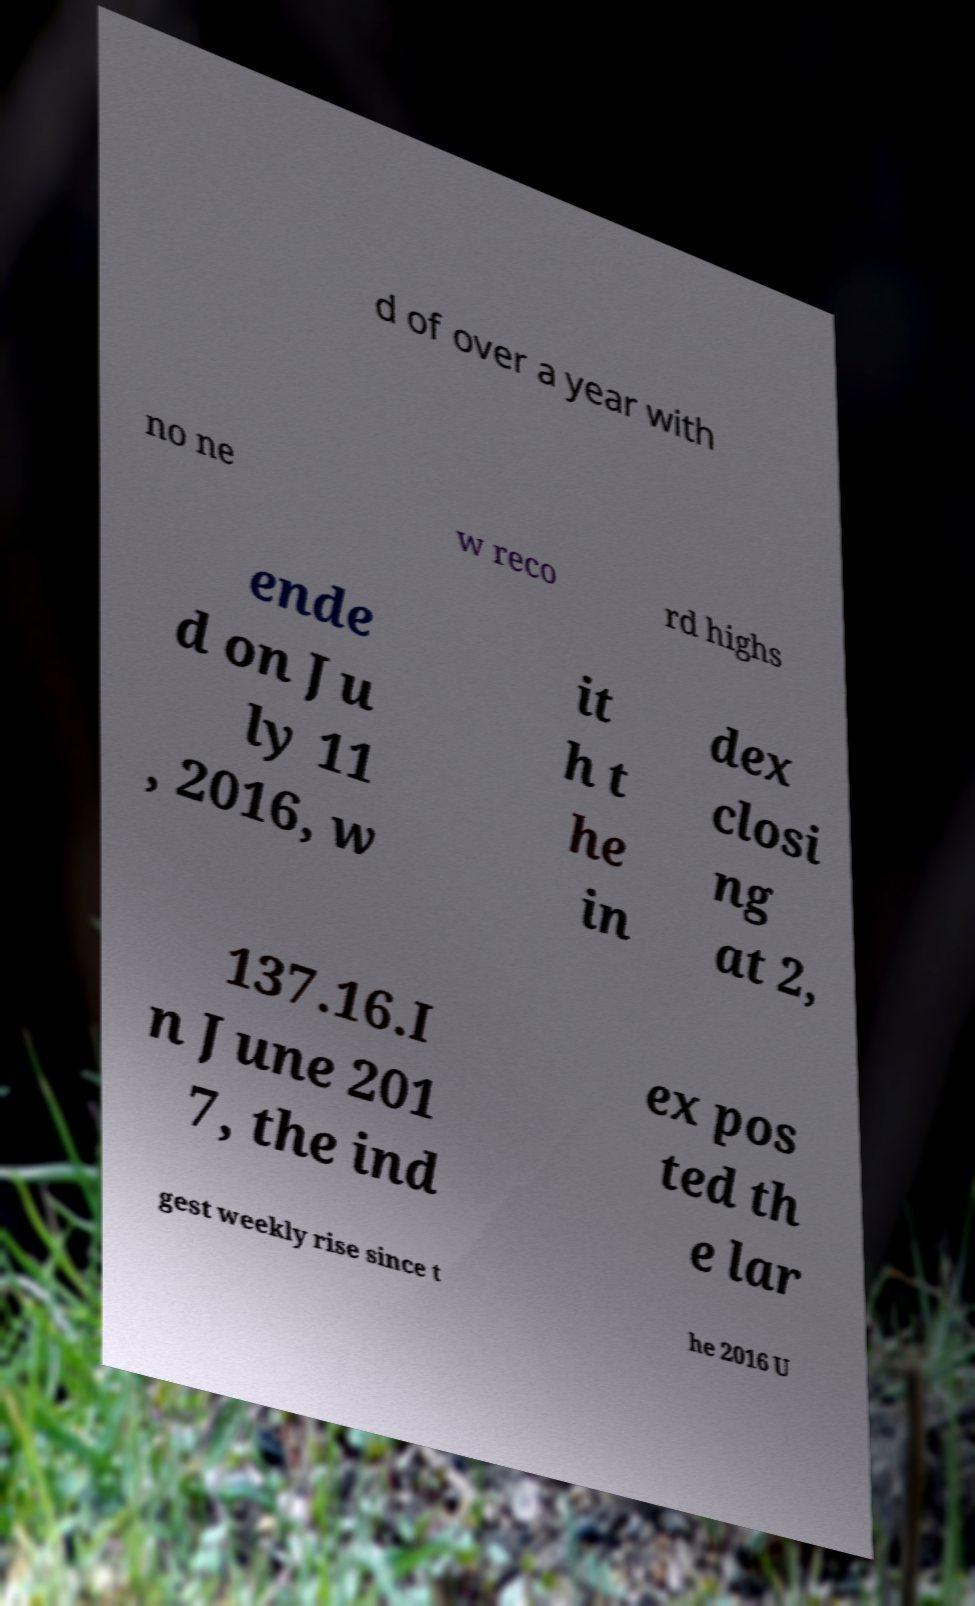What messages or text are displayed in this image? I need them in a readable, typed format. d of over a year with no ne w reco rd highs ende d on Ju ly 11 , 2016, w it h t he in dex closi ng at 2, 137.16.I n June 201 7, the ind ex pos ted th e lar gest weekly rise since t he 2016 U 